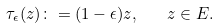Convert formula to latex. <formula><loc_0><loc_0><loc_500><loc_500>\tau _ { \epsilon } ( z ) \colon = ( 1 - \epsilon ) z , \quad z \in E .</formula> 